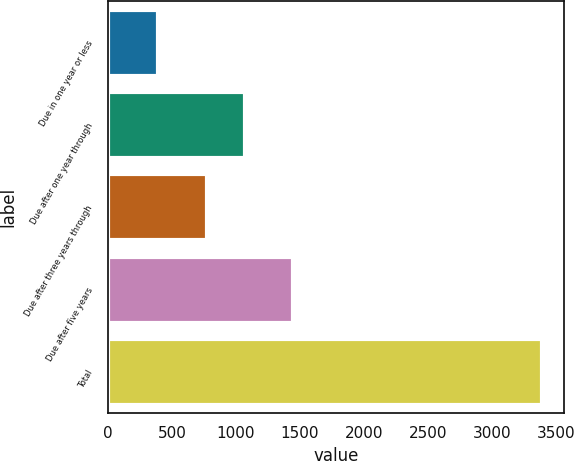<chart> <loc_0><loc_0><loc_500><loc_500><bar_chart><fcel>Due in one year or less<fcel>Due after one year through<fcel>Due after three years through<fcel>Due after five years<fcel>Total<nl><fcel>394.3<fcel>1074.01<fcel>774.3<fcel>1446.8<fcel>3391.4<nl></chart> 